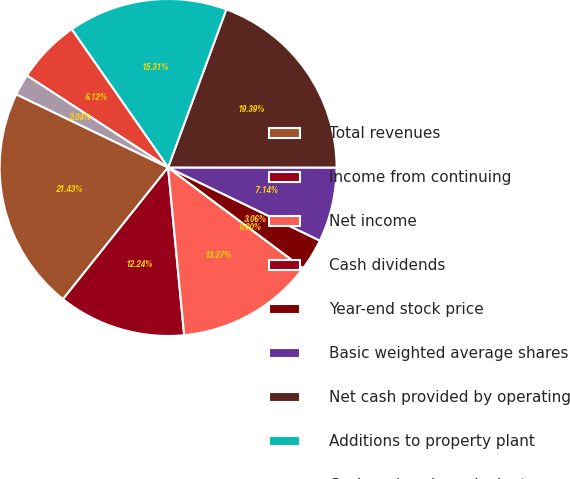Convert chart. <chart><loc_0><loc_0><loc_500><loc_500><pie_chart><fcel>Total revenues<fcel>Income from continuing<fcel>Net income<fcel>Cash dividends<fcel>Year-end stock price<fcel>Basic weighted average shares<fcel>Net cash provided by operating<fcel>Additions to property plant<fcel>Cash and cash equivalents<fcel>Commodity derivative<nl><fcel>21.43%<fcel>12.24%<fcel>13.27%<fcel>0.0%<fcel>3.06%<fcel>7.14%<fcel>19.39%<fcel>15.31%<fcel>6.12%<fcel>2.04%<nl></chart> 